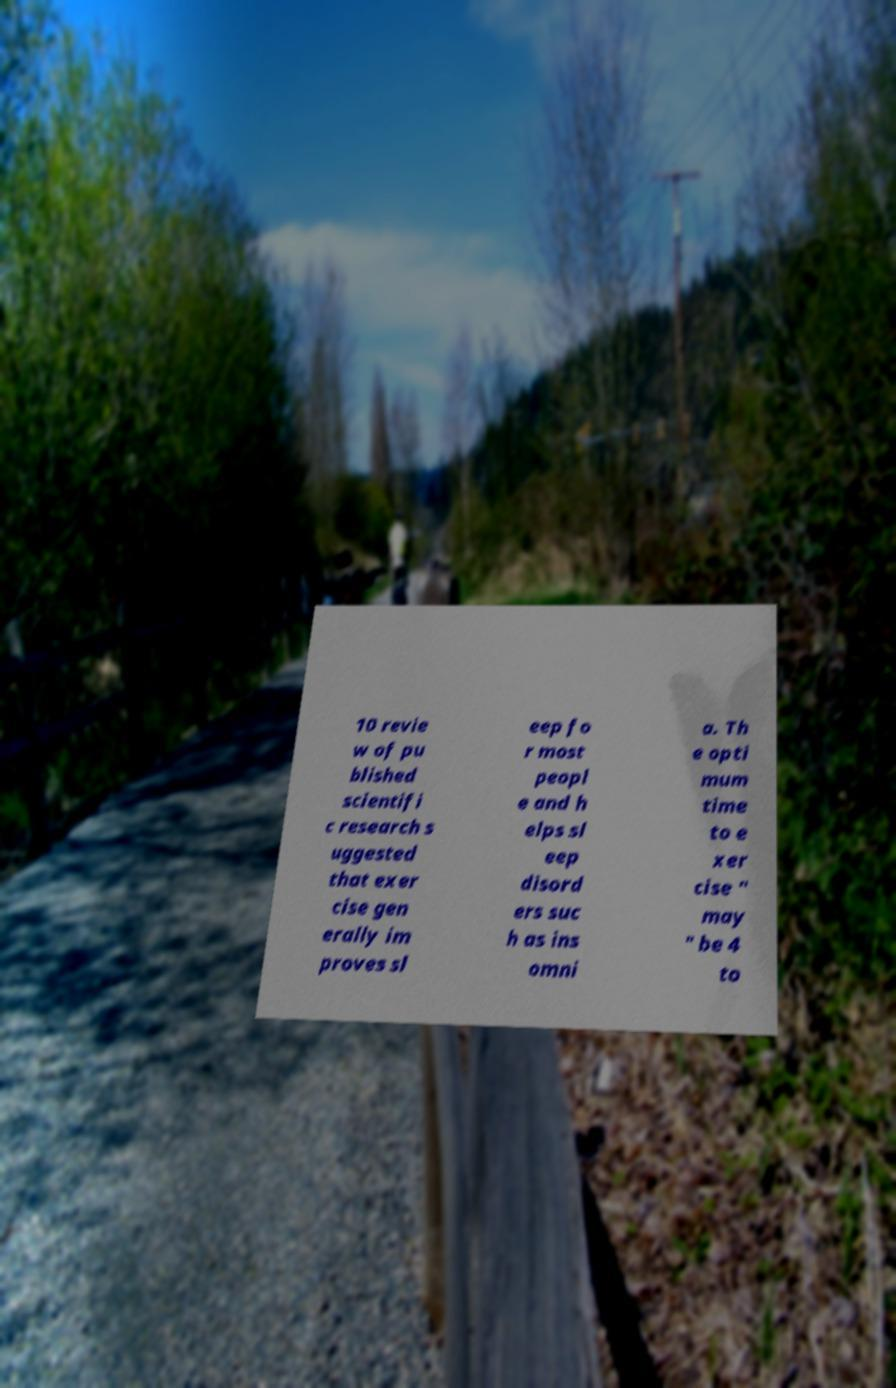Can you accurately transcribe the text from the provided image for me? 10 revie w of pu blished scientifi c research s uggested that exer cise gen erally im proves sl eep fo r most peopl e and h elps sl eep disord ers suc h as ins omni a. Th e opti mum time to e xer cise " may " be 4 to 